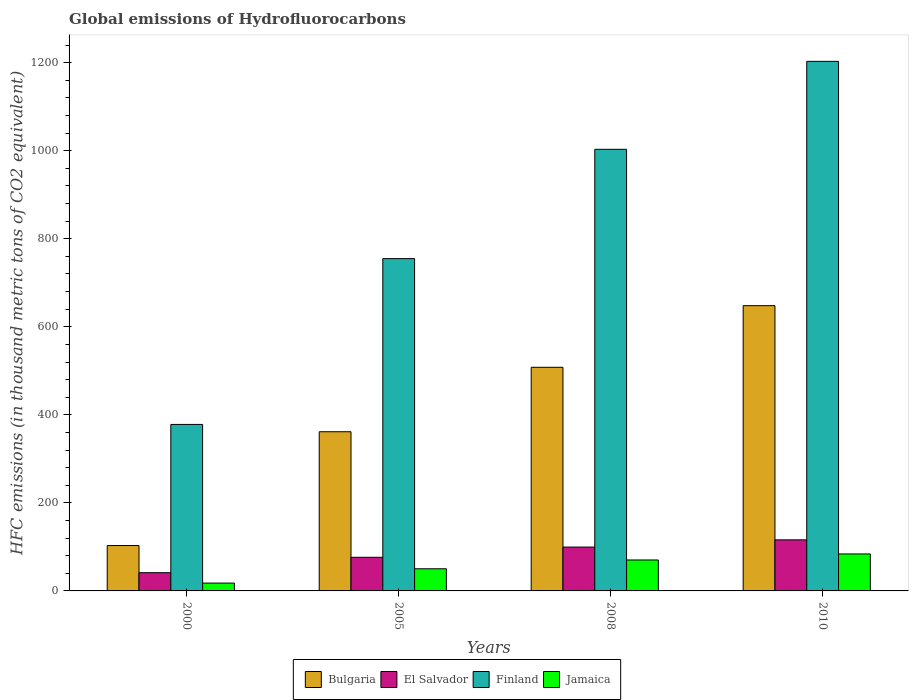How many different coloured bars are there?
Your answer should be compact. 4. Are the number of bars on each tick of the X-axis equal?
Your answer should be compact. Yes. What is the global emissions of Hydrofluorocarbons in Finland in 2000?
Your answer should be very brief. 378.2. Across all years, what is the maximum global emissions of Hydrofluorocarbons in Bulgaria?
Offer a terse response. 648. Across all years, what is the minimum global emissions of Hydrofluorocarbons in El Salvador?
Provide a short and direct response. 41.4. In which year was the global emissions of Hydrofluorocarbons in Bulgaria maximum?
Your response must be concise. 2010. In which year was the global emissions of Hydrofluorocarbons in Bulgaria minimum?
Give a very brief answer. 2000. What is the total global emissions of Hydrofluorocarbons in Bulgaria in the graph?
Ensure brevity in your answer.  1620.7. What is the difference between the global emissions of Hydrofluorocarbons in Bulgaria in 2000 and that in 2010?
Provide a short and direct response. -544.9. What is the difference between the global emissions of Hydrofluorocarbons in Jamaica in 2008 and the global emissions of Hydrofluorocarbons in Bulgaria in 2010?
Keep it short and to the point. -577.7. What is the average global emissions of Hydrofluorocarbons in Finland per year?
Offer a very short reply. 834.83. In the year 2010, what is the difference between the global emissions of Hydrofluorocarbons in Bulgaria and global emissions of Hydrofluorocarbons in Finland?
Keep it short and to the point. -555. In how many years, is the global emissions of Hydrofluorocarbons in El Salvador greater than 200 thousand metric tons?
Keep it short and to the point. 0. What is the ratio of the global emissions of Hydrofluorocarbons in El Salvador in 2000 to that in 2008?
Ensure brevity in your answer.  0.42. Is the global emissions of Hydrofluorocarbons in Jamaica in 2008 less than that in 2010?
Give a very brief answer. Yes. What is the difference between the highest and the second highest global emissions of Hydrofluorocarbons in Finland?
Ensure brevity in your answer.  199.8. What is the difference between the highest and the lowest global emissions of Hydrofluorocarbons in El Salvador?
Ensure brevity in your answer.  74.6. Is the sum of the global emissions of Hydrofluorocarbons in El Salvador in 2000 and 2005 greater than the maximum global emissions of Hydrofluorocarbons in Jamaica across all years?
Make the answer very short. Yes. What does the 3rd bar from the left in 2005 represents?
Give a very brief answer. Finland. What does the 1st bar from the right in 2000 represents?
Make the answer very short. Jamaica. Is it the case that in every year, the sum of the global emissions of Hydrofluorocarbons in Finland and global emissions of Hydrofluorocarbons in El Salvador is greater than the global emissions of Hydrofluorocarbons in Bulgaria?
Make the answer very short. Yes. How many bars are there?
Provide a short and direct response. 16. How many years are there in the graph?
Your answer should be compact. 4. Where does the legend appear in the graph?
Offer a terse response. Bottom center. How many legend labels are there?
Ensure brevity in your answer.  4. How are the legend labels stacked?
Offer a very short reply. Horizontal. What is the title of the graph?
Offer a terse response. Global emissions of Hydrofluorocarbons. Does "Montenegro" appear as one of the legend labels in the graph?
Your answer should be very brief. No. What is the label or title of the X-axis?
Provide a short and direct response. Years. What is the label or title of the Y-axis?
Offer a terse response. HFC emissions (in thousand metric tons of CO2 equivalent). What is the HFC emissions (in thousand metric tons of CO2 equivalent) of Bulgaria in 2000?
Ensure brevity in your answer.  103.1. What is the HFC emissions (in thousand metric tons of CO2 equivalent) in El Salvador in 2000?
Offer a terse response. 41.4. What is the HFC emissions (in thousand metric tons of CO2 equivalent) of Finland in 2000?
Your answer should be very brief. 378.2. What is the HFC emissions (in thousand metric tons of CO2 equivalent) of Jamaica in 2000?
Provide a succinct answer. 17.8. What is the HFC emissions (in thousand metric tons of CO2 equivalent) in Bulgaria in 2005?
Ensure brevity in your answer.  361.6. What is the HFC emissions (in thousand metric tons of CO2 equivalent) of El Salvador in 2005?
Ensure brevity in your answer.  76.4. What is the HFC emissions (in thousand metric tons of CO2 equivalent) of Finland in 2005?
Your response must be concise. 754.9. What is the HFC emissions (in thousand metric tons of CO2 equivalent) in Jamaica in 2005?
Ensure brevity in your answer.  50.3. What is the HFC emissions (in thousand metric tons of CO2 equivalent) of Bulgaria in 2008?
Offer a terse response. 508. What is the HFC emissions (in thousand metric tons of CO2 equivalent) in El Salvador in 2008?
Make the answer very short. 99.6. What is the HFC emissions (in thousand metric tons of CO2 equivalent) in Finland in 2008?
Provide a short and direct response. 1003.2. What is the HFC emissions (in thousand metric tons of CO2 equivalent) of Jamaica in 2008?
Offer a very short reply. 70.3. What is the HFC emissions (in thousand metric tons of CO2 equivalent) in Bulgaria in 2010?
Give a very brief answer. 648. What is the HFC emissions (in thousand metric tons of CO2 equivalent) in El Salvador in 2010?
Make the answer very short. 116. What is the HFC emissions (in thousand metric tons of CO2 equivalent) of Finland in 2010?
Provide a succinct answer. 1203. What is the HFC emissions (in thousand metric tons of CO2 equivalent) in Jamaica in 2010?
Your answer should be compact. 84. Across all years, what is the maximum HFC emissions (in thousand metric tons of CO2 equivalent) in Bulgaria?
Keep it short and to the point. 648. Across all years, what is the maximum HFC emissions (in thousand metric tons of CO2 equivalent) in El Salvador?
Provide a succinct answer. 116. Across all years, what is the maximum HFC emissions (in thousand metric tons of CO2 equivalent) of Finland?
Offer a terse response. 1203. Across all years, what is the minimum HFC emissions (in thousand metric tons of CO2 equivalent) of Bulgaria?
Make the answer very short. 103.1. Across all years, what is the minimum HFC emissions (in thousand metric tons of CO2 equivalent) of El Salvador?
Your answer should be very brief. 41.4. Across all years, what is the minimum HFC emissions (in thousand metric tons of CO2 equivalent) of Finland?
Ensure brevity in your answer.  378.2. What is the total HFC emissions (in thousand metric tons of CO2 equivalent) of Bulgaria in the graph?
Provide a succinct answer. 1620.7. What is the total HFC emissions (in thousand metric tons of CO2 equivalent) of El Salvador in the graph?
Offer a very short reply. 333.4. What is the total HFC emissions (in thousand metric tons of CO2 equivalent) of Finland in the graph?
Your answer should be very brief. 3339.3. What is the total HFC emissions (in thousand metric tons of CO2 equivalent) of Jamaica in the graph?
Give a very brief answer. 222.4. What is the difference between the HFC emissions (in thousand metric tons of CO2 equivalent) in Bulgaria in 2000 and that in 2005?
Your response must be concise. -258.5. What is the difference between the HFC emissions (in thousand metric tons of CO2 equivalent) of El Salvador in 2000 and that in 2005?
Make the answer very short. -35. What is the difference between the HFC emissions (in thousand metric tons of CO2 equivalent) in Finland in 2000 and that in 2005?
Offer a very short reply. -376.7. What is the difference between the HFC emissions (in thousand metric tons of CO2 equivalent) of Jamaica in 2000 and that in 2005?
Provide a succinct answer. -32.5. What is the difference between the HFC emissions (in thousand metric tons of CO2 equivalent) of Bulgaria in 2000 and that in 2008?
Make the answer very short. -404.9. What is the difference between the HFC emissions (in thousand metric tons of CO2 equivalent) in El Salvador in 2000 and that in 2008?
Offer a very short reply. -58.2. What is the difference between the HFC emissions (in thousand metric tons of CO2 equivalent) of Finland in 2000 and that in 2008?
Ensure brevity in your answer.  -625. What is the difference between the HFC emissions (in thousand metric tons of CO2 equivalent) in Jamaica in 2000 and that in 2008?
Your answer should be compact. -52.5. What is the difference between the HFC emissions (in thousand metric tons of CO2 equivalent) in Bulgaria in 2000 and that in 2010?
Provide a short and direct response. -544.9. What is the difference between the HFC emissions (in thousand metric tons of CO2 equivalent) of El Salvador in 2000 and that in 2010?
Keep it short and to the point. -74.6. What is the difference between the HFC emissions (in thousand metric tons of CO2 equivalent) of Finland in 2000 and that in 2010?
Your answer should be compact. -824.8. What is the difference between the HFC emissions (in thousand metric tons of CO2 equivalent) in Jamaica in 2000 and that in 2010?
Your answer should be compact. -66.2. What is the difference between the HFC emissions (in thousand metric tons of CO2 equivalent) in Bulgaria in 2005 and that in 2008?
Offer a terse response. -146.4. What is the difference between the HFC emissions (in thousand metric tons of CO2 equivalent) in El Salvador in 2005 and that in 2008?
Your response must be concise. -23.2. What is the difference between the HFC emissions (in thousand metric tons of CO2 equivalent) in Finland in 2005 and that in 2008?
Ensure brevity in your answer.  -248.3. What is the difference between the HFC emissions (in thousand metric tons of CO2 equivalent) of Jamaica in 2005 and that in 2008?
Ensure brevity in your answer.  -20. What is the difference between the HFC emissions (in thousand metric tons of CO2 equivalent) of Bulgaria in 2005 and that in 2010?
Ensure brevity in your answer.  -286.4. What is the difference between the HFC emissions (in thousand metric tons of CO2 equivalent) in El Salvador in 2005 and that in 2010?
Offer a very short reply. -39.6. What is the difference between the HFC emissions (in thousand metric tons of CO2 equivalent) in Finland in 2005 and that in 2010?
Your response must be concise. -448.1. What is the difference between the HFC emissions (in thousand metric tons of CO2 equivalent) in Jamaica in 2005 and that in 2010?
Give a very brief answer. -33.7. What is the difference between the HFC emissions (in thousand metric tons of CO2 equivalent) in Bulgaria in 2008 and that in 2010?
Keep it short and to the point. -140. What is the difference between the HFC emissions (in thousand metric tons of CO2 equivalent) in El Salvador in 2008 and that in 2010?
Your answer should be very brief. -16.4. What is the difference between the HFC emissions (in thousand metric tons of CO2 equivalent) of Finland in 2008 and that in 2010?
Offer a very short reply. -199.8. What is the difference between the HFC emissions (in thousand metric tons of CO2 equivalent) in Jamaica in 2008 and that in 2010?
Your response must be concise. -13.7. What is the difference between the HFC emissions (in thousand metric tons of CO2 equivalent) of Bulgaria in 2000 and the HFC emissions (in thousand metric tons of CO2 equivalent) of El Salvador in 2005?
Your answer should be compact. 26.7. What is the difference between the HFC emissions (in thousand metric tons of CO2 equivalent) of Bulgaria in 2000 and the HFC emissions (in thousand metric tons of CO2 equivalent) of Finland in 2005?
Your answer should be very brief. -651.8. What is the difference between the HFC emissions (in thousand metric tons of CO2 equivalent) in Bulgaria in 2000 and the HFC emissions (in thousand metric tons of CO2 equivalent) in Jamaica in 2005?
Ensure brevity in your answer.  52.8. What is the difference between the HFC emissions (in thousand metric tons of CO2 equivalent) of El Salvador in 2000 and the HFC emissions (in thousand metric tons of CO2 equivalent) of Finland in 2005?
Ensure brevity in your answer.  -713.5. What is the difference between the HFC emissions (in thousand metric tons of CO2 equivalent) of El Salvador in 2000 and the HFC emissions (in thousand metric tons of CO2 equivalent) of Jamaica in 2005?
Offer a terse response. -8.9. What is the difference between the HFC emissions (in thousand metric tons of CO2 equivalent) in Finland in 2000 and the HFC emissions (in thousand metric tons of CO2 equivalent) in Jamaica in 2005?
Make the answer very short. 327.9. What is the difference between the HFC emissions (in thousand metric tons of CO2 equivalent) of Bulgaria in 2000 and the HFC emissions (in thousand metric tons of CO2 equivalent) of Finland in 2008?
Provide a succinct answer. -900.1. What is the difference between the HFC emissions (in thousand metric tons of CO2 equivalent) in Bulgaria in 2000 and the HFC emissions (in thousand metric tons of CO2 equivalent) in Jamaica in 2008?
Provide a short and direct response. 32.8. What is the difference between the HFC emissions (in thousand metric tons of CO2 equivalent) of El Salvador in 2000 and the HFC emissions (in thousand metric tons of CO2 equivalent) of Finland in 2008?
Keep it short and to the point. -961.8. What is the difference between the HFC emissions (in thousand metric tons of CO2 equivalent) in El Salvador in 2000 and the HFC emissions (in thousand metric tons of CO2 equivalent) in Jamaica in 2008?
Keep it short and to the point. -28.9. What is the difference between the HFC emissions (in thousand metric tons of CO2 equivalent) in Finland in 2000 and the HFC emissions (in thousand metric tons of CO2 equivalent) in Jamaica in 2008?
Your response must be concise. 307.9. What is the difference between the HFC emissions (in thousand metric tons of CO2 equivalent) in Bulgaria in 2000 and the HFC emissions (in thousand metric tons of CO2 equivalent) in Finland in 2010?
Your answer should be very brief. -1099.9. What is the difference between the HFC emissions (in thousand metric tons of CO2 equivalent) of Bulgaria in 2000 and the HFC emissions (in thousand metric tons of CO2 equivalent) of Jamaica in 2010?
Offer a terse response. 19.1. What is the difference between the HFC emissions (in thousand metric tons of CO2 equivalent) in El Salvador in 2000 and the HFC emissions (in thousand metric tons of CO2 equivalent) in Finland in 2010?
Give a very brief answer. -1161.6. What is the difference between the HFC emissions (in thousand metric tons of CO2 equivalent) in El Salvador in 2000 and the HFC emissions (in thousand metric tons of CO2 equivalent) in Jamaica in 2010?
Your response must be concise. -42.6. What is the difference between the HFC emissions (in thousand metric tons of CO2 equivalent) of Finland in 2000 and the HFC emissions (in thousand metric tons of CO2 equivalent) of Jamaica in 2010?
Give a very brief answer. 294.2. What is the difference between the HFC emissions (in thousand metric tons of CO2 equivalent) of Bulgaria in 2005 and the HFC emissions (in thousand metric tons of CO2 equivalent) of El Salvador in 2008?
Ensure brevity in your answer.  262. What is the difference between the HFC emissions (in thousand metric tons of CO2 equivalent) of Bulgaria in 2005 and the HFC emissions (in thousand metric tons of CO2 equivalent) of Finland in 2008?
Your response must be concise. -641.6. What is the difference between the HFC emissions (in thousand metric tons of CO2 equivalent) in Bulgaria in 2005 and the HFC emissions (in thousand metric tons of CO2 equivalent) in Jamaica in 2008?
Offer a very short reply. 291.3. What is the difference between the HFC emissions (in thousand metric tons of CO2 equivalent) of El Salvador in 2005 and the HFC emissions (in thousand metric tons of CO2 equivalent) of Finland in 2008?
Make the answer very short. -926.8. What is the difference between the HFC emissions (in thousand metric tons of CO2 equivalent) of El Salvador in 2005 and the HFC emissions (in thousand metric tons of CO2 equivalent) of Jamaica in 2008?
Your answer should be very brief. 6.1. What is the difference between the HFC emissions (in thousand metric tons of CO2 equivalent) in Finland in 2005 and the HFC emissions (in thousand metric tons of CO2 equivalent) in Jamaica in 2008?
Provide a short and direct response. 684.6. What is the difference between the HFC emissions (in thousand metric tons of CO2 equivalent) in Bulgaria in 2005 and the HFC emissions (in thousand metric tons of CO2 equivalent) in El Salvador in 2010?
Offer a terse response. 245.6. What is the difference between the HFC emissions (in thousand metric tons of CO2 equivalent) in Bulgaria in 2005 and the HFC emissions (in thousand metric tons of CO2 equivalent) in Finland in 2010?
Provide a succinct answer. -841.4. What is the difference between the HFC emissions (in thousand metric tons of CO2 equivalent) of Bulgaria in 2005 and the HFC emissions (in thousand metric tons of CO2 equivalent) of Jamaica in 2010?
Make the answer very short. 277.6. What is the difference between the HFC emissions (in thousand metric tons of CO2 equivalent) in El Salvador in 2005 and the HFC emissions (in thousand metric tons of CO2 equivalent) in Finland in 2010?
Ensure brevity in your answer.  -1126.6. What is the difference between the HFC emissions (in thousand metric tons of CO2 equivalent) in El Salvador in 2005 and the HFC emissions (in thousand metric tons of CO2 equivalent) in Jamaica in 2010?
Your answer should be compact. -7.6. What is the difference between the HFC emissions (in thousand metric tons of CO2 equivalent) in Finland in 2005 and the HFC emissions (in thousand metric tons of CO2 equivalent) in Jamaica in 2010?
Keep it short and to the point. 670.9. What is the difference between the HFC emissions (in thousand metric tons of CO2 equivalent) in Bulgaria in 2008 and the HFC emissions (in thousand metric tons of CO2 equivalent) in El Salvador in 2010?
Offer a terse response. 392. What is the difference between the HFC emissions (in thousand metric tons of CO2 equivalent) in Bulgaria in 2008 and the HFC emissions (in thousand metric tons of CO2 equivalent) in Finland in 2010?
Give a very brief answer. -695. What is the difference between the HFC emissions (in thousand metric tons of CO2 equivalent) of Bulgaria in 2008 and the HFC emissions (in thousand metric tons of CO2 equivalent) of Jamaica in 2010?
Make the answer very short. 424. What is the difference between the HFC emissions (in thousand metric tons of CO2 equivalent) of El Salvador in 2008 and the HFC emissions (in thousand metric tons of CO2 equivalent) of Finland in 2010?
Provide a succinct answer. -1103.4. What is the difference between the HFC emissions (in thousand metric tons of CO2 equivalent) of Finland in 2008 and the HFC emissions (in thousand metric tons of CO2 equivalent) of Jamaica in 2010?
Keep it short and to the point. 919.2. What is the average HFC emissions (in thousand metric tons of CO2 equivalent) of Bulgaria per year?
Offer a terse response. 405.18. What is the average HFC emissions (in thousand metric tons of CO2 equivalent) of El Salvador per year?
Give a very brief answer. 83.35. What is the average HFC emissions (in thousand metric tons of CO2 equivalent) of Finland per year?
Your response must be concise. 834.83. What is the average HFC emissions (in thousand metric tons of CO2 equivalent) of Jamaica per year?
Your answer should be very brief. 55.6. In the year 2000, what is the difference between the HFC emissions (in thousand metric tons of CO2 equivalent) of Bulgaria and HFC emissions (in thousand metric tons of CO2 equivalent) of El Salvador?
Offer a very short reply. 61.7. In the year 2000, what is the difference between the HFC emissions (in thousand metric tons of CO2 equivalent) in Bulgaria and HFC emissions (in thousand metric tons of CO2 equivalent) in Finland?
Your answer should be very brief. -275.1. In the year 2000, what is the difference between the HFC emissions (in thousand metric tons of CO2 equivalent) in Bulgaria and HFC emissions (in thousand metric tons of CO2 equivalent) in Jamaica?
Your answer should be compact. 85.3. In the year 2000, what is the difference between the HFC emissions (in thousand metric tons of CO2 equivalent) of El Salvador and HFC emissions (in thousand metric tons of CO2 equivalent) of Finland?
Offer a very short reply. -336.8. In the year 2000, what is the difference between the HFC emissions (in thousand metric tons of CO2 equivalent) of El Salvador and HFC emissions (in thousand metric tons of CO2 equivalent) of Jamaica?
Ensure brevity in your answer.  23.6. In the year 2000, what is the difference between the HFC emissions (in thousand metric tons of CO2 equivalent) of Finland and HFC emissions (in thousand metric tons of CO2 equivalent) of Jamaica?
Keep it short and to the point. 360.4. In the year 2005, what is the difference between the HFC emissions (in thousand metric tons of CO2 equivalent) of Bulgaria and HFC emissions (in thousand metric tons of CO2 equivalent) of El Salvador?
Make the answer very short. 285.2. In the year 2005, what is the difference between the HFC emissions (in thousand metric tons of CO2 equivalent) in Bulgaria and HFC emissions (in thousand metric tons of CO2 equivalent) in Finland?
Your answer should be very brief. -393.3. In the year 2005, what is the difference between the HFC emissions (in thousand metric tons of CO2 equivalent) in Bulgaria and HFC emissions (in thousand metric tons of CO2 equivalent) in Jamaica?
Your answer should be very brief. 311.3. In the year 2005, what is the difference between the HFC emissions (in thousand metric tons of CO2 equivalent) in El Salvador and HFC emissions (in thousand metric tons of CO2 equivalent) in Finland?
Your answer should be compact. -678.5. In the year 2005, what is the difference between the HFC emissions (in thousand metric tons of CO2 equivalent) of El Salvador and HFC emissions (in thousand metric tons of CO2 equivalent) of Jamaica?
Your answer should be very brief. 26.1. In the year 2005, what is the difference between the HFC emissions (in thousand metric tons of CO2 equivalent) of Finland and HFC emissions (in thousand metric tons of CO2 equivalent) of Jamaica?
Ensure brevity in your answer.  704.6. In the year 2008, what is the difference between the HFC emissions (in thousand metric tons of CO2 equivalent) in Bulgaria and HFC emissions (in thousand metric tons of CO2 equivalent) in El Salvador?
Offer a very short reply. 408.4. In the year 2008, what is the difference between the HFC emissions (in thousand metric tons of CO2 equivalent) in Bulgaria and HFC emissions (in thousand metric tons of CO2 equivalent) in Finland?
Offer a very short reply. -495.2. In the year 2008, what is the difference between the HFC emissions (in thousand metric tons of CO2 equivalent) in Bulgaria and HFC emissions (in thousand metric tons of CO2 equivalent) in Jamaica?
Your response must be concise. 437.7. In the year 2008, what is the difference between the HFC emissions (in thousand metric tons of CO2 equivalent) in El Salvador and HFC emissions (in thousand metric tons of CO2 equivalent) in Finland?
Your answer should be very brief. -903.6. In the year 2008, what is the difference between the HFC emissions (in thousand metric tons of CO2 equivalent) of El Salvador and HFC emissions (in thousand metric tons of CO2 equivalent) of Jamaica?
Keep it short and to the point. 29.3. In the year 2008, what is the difference between the HFC emissions (in thousand metric tons of CO2 equivalent) of Finland and HFC emissions (in thousand metric tons of CO2 equivalent) of Jamaica?
Ensure brevity in your answer.  932.9. In the year 2010, what is the difference between the HFC emissions (in thousand metric tons of CO2 equivalent) of Bulgaria and HFC emissions (in thousand metric tons of CO2 equivalent) of El Salvador?
Your answer should be very brief. 532. In the year 2010, what is the difference between the HFC emissions (in thousand metric tons of CO2 equivalent) of Bulgaria and HFC emissions (in thousand metric tons of CO2 equivalent) of Finland?
Your answer should be compact. -555. In the year 2010, what is the difference between the HFC emissions (in thousand metric tons of CO2 equivalent) of Bulgaria and HFC emissions (in thousand metric tons of CO2 equivalent) of Jamaica?
Make the answer very short. 564. In the year 2010, what is the difference between the HFC emissions (in thousand metric tons of CO2 equivalent) in El Salvador and HFC emissions (in thousand metric tons of CO2 equivalent) in Finland?
Give a very brief answer. -1087. In the year 2010, what is the difference between the HFC emissions (in thousand metric tons of CO2 equivalent) of El Salvador and HFC emissions (in thousand metric tons of CO2 equivalent) of Jamaica?
Your answer should be compact. 32. In the year 2010, what is the difference between the HFC emissions (in thousand metric tons of CO2 equivalent) of Finland and HFC emissions (in thousand metric tons of CO2 equivalent) of Jamaica?
Your response must be concise. 1119. What is the ratio of the HFC emissions (in thousand metric tons of CO2 equivalent) in Bulgaria in 2000 to that in 2005?
Your response must be concise. 0.29. What is the ratio of the HFC emissions (in thousand metric tons of CO2 equivalent) of El Salvador in 2000 to that in 2005?
Your answer should be very brief. 0.54. What is the ratio of the HFC emissions (in thousand metric tons of CO2 equivalent) in Finland in 2000 to that in 2005?
Ensure brevity in your answer.  0.5. What is the ratio of the HFC emissions (in thousand metric tons of CO2 equivalent) of Jamaica in 2000 to that in 2005?
Make the answer very short. 0.35. What is the ratio of the HFC emissions (in thousand metric tons of CO2 equivalent) of Bulgaria in 2000 to that in 2008?
Provide a short and direct response. 0.2. What is the ratio of the HFC emissions (in thousand metric tons of CO2 equivalent) in El Salvador in 2000 to that in 2008?
Keep it short and to the point. 0.42. What is the ratio of the HFC emissions (in thousand metric tons of CO2 equivalent) of Finland in 2000 to that in 2008?
Provide a succinct answer. 0.38. What is the ratio of the HFC emissions (in thousand metric tons of CO2 equivalent) of Jamaica in 2000 to that in 2008?
Your answer should be compact. 0.25. What is the ratio of the HFC emissions (in thousand metric tons of CO2 equivalent) of Bulgaria in 2000 to that in 2010?
Give a very brief answer. 0.16. What is the ratio of the HFC emissions (in thousand metric tons of CO2 equivalent) in El Salvador in 2000 to that in 2010?
Offer a terse response. 0.36. What is the ratio of the HFC emissions (in thousand metric tons of CO2 equivalent) in Finland in 2000 to that in 2010?
Your answer should be compact. 0.31. What is the ratio of the HFC emissions (in thousand metric tons of CO2 equivalent) of Jamaica in 2000 to that in 2010?
Offer a very short reply. 0.21. What is the ratio of the HFC emissions (in thousand metric tons of CO2 equivalent) in Bulgaria in 2005 to that in 2008?
Ensure brevity in your answer.  0.71. What is the ratio of the HFC emissions (in thousand metric tons of CO2 equivalent) of El Salvador in 2005 to that in 2008?
Make the answer very short. 0.77. What is the ratio of the HFC emissions (in thousand metric tons of CO2 equivalent) of Finland in 2005 to that in 2008?
Make the answer very short. 0.75. What is the ratio of the HFC emissions (in thousand metric tons of CO2 equivalent) of Jamaica in 2005 to that in 2008?
Provide a succinct answer. 0.72. What is the ratio of the HFC emissions (in thousand metric tons of CO2 equivalent) of Bulgaria in 2005 to that in 2010?
Provide a short and direct response. 0.56. What is the ratio of the HFC emissions (in thousand metric tons of CO2 equivalent) of El Salvador in 2005 to that in 2010?
Provide a short and direct response. 0.66. What is the ratio of the HFC emissions (in thousand metric tons of CO2 equivalent) of Finland in 2005 to that in 2010?
Your response must be concise. 0.63. What is the ratio of the HFC emissions (in thousand metric tons of CO2 equivalent) in Jamaica in 2005 to that in 2010?
Offer a very short reply. 0.6. What is the ratio of the HFC emissions (in thousand metric tons of CO2 equivalent) of Bulgaria in 2008 to that in 2010?
Offer a very short reply. 0.78. What is the ratio of the HFC emissions (in thousand metric tons of CO2 equivalent) in El Salvador in 2008 to that in 2010?
Offer a terse response. 0.86. What is the ratio of the HFC emissions (in thousand metric tons of CO2 equivalent) of Finland in 2008 to that in 2010?
Provide a short and direct response. 0.83. What is the ratio of the HFC emissions (in thousand metric tons of CO2 equivalent) in Jamaica in 2008 to that in 2010?
Make the answer very short. 0.84. What is the difference between the highest and the second highest HFC emissions (in thousand metric tons of CO2 equivalent) of Bulgaria?
Provide a succinct answer. 140. What is the difference between the highest and the second highest HFC emissions (in thousand metric tons of CO2 equivalent) in Finland?
Keep it short and to the point. 199.8. What is the difference between the highest and the second highest HFC emissions (in thousand metric tons of CO2 equivalent) of Jamaica?
Ensure brevity in your answer.  13.7. What is the difference between the highest and the lowest HFC emissions (in thousand metric tons of CO2 equivalent) in Bulgaria?
Keep it short and to the point. 544.9. What is the difference between the highest and the lowest HFC emissions (in thousand metric tons of CO2 equivalent) of El Salvador?
Offer a terse response. 74.6. What is the difference between the highest and the lowest HFC emissions (in thousand metric tons of CO2 equivalent) in Finland?
Offer a terse response. 824.8. What is the difference between the highest and the lowest HFC emissions (in thousand metric tons of CO2 equivalent) in Jamaica?
Your answer should be very brief. 66.2. 